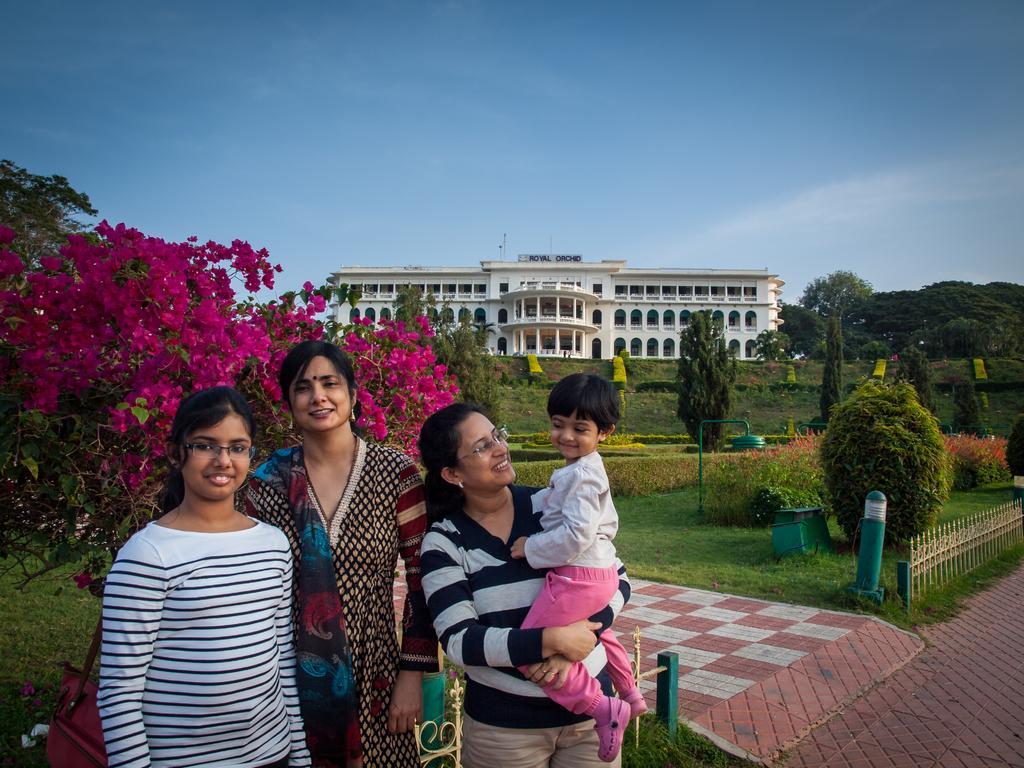Could you give a brief overview of what you see in this image? In this image we can see a group of people standing. In that a woman is carrying a child. On the backside we can see a group of trees, plants with flowers, pole, fence, a building with windows and the sky which looks cloudy. 